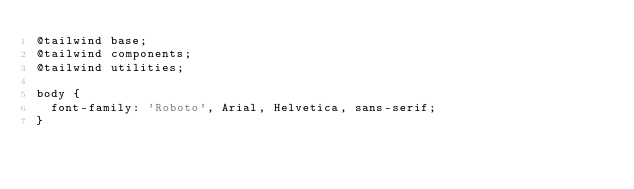Convert code to text. <code><loc_0><loc_0><loc_500><loc_500><_CSS_>@tailwind base;
@tailwind components;
@tailwind utilities;

body {
  font-family: 'Roboto', Arial, Helvetica, sans-serif;
}
</code> 